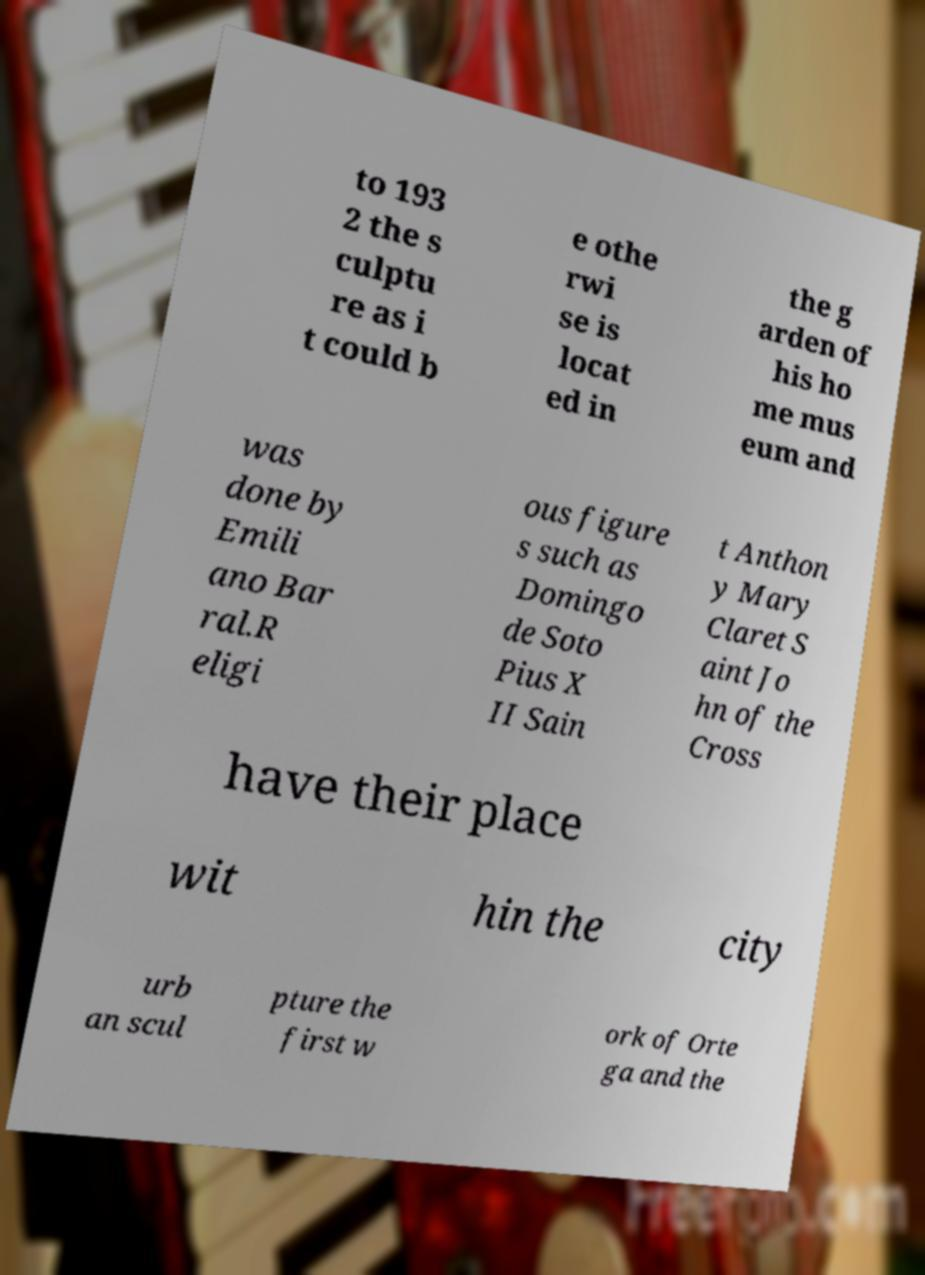There's text embedded in this image that I need extracted. Can you transcribe it verbatim? to 193 2 the s culptu re as i t could b e othe rwi se is locat ed in the g arden of his ho me mus eum and was done by Emili ano Bar ral.R eligi ous figure s such as Domingo de Soto Pius X II Sain t Anthon y Mary Claret S aint Jo hn of the Cross have their place wit hin the city urb an scul pture the first w ork of Orte ga and the 